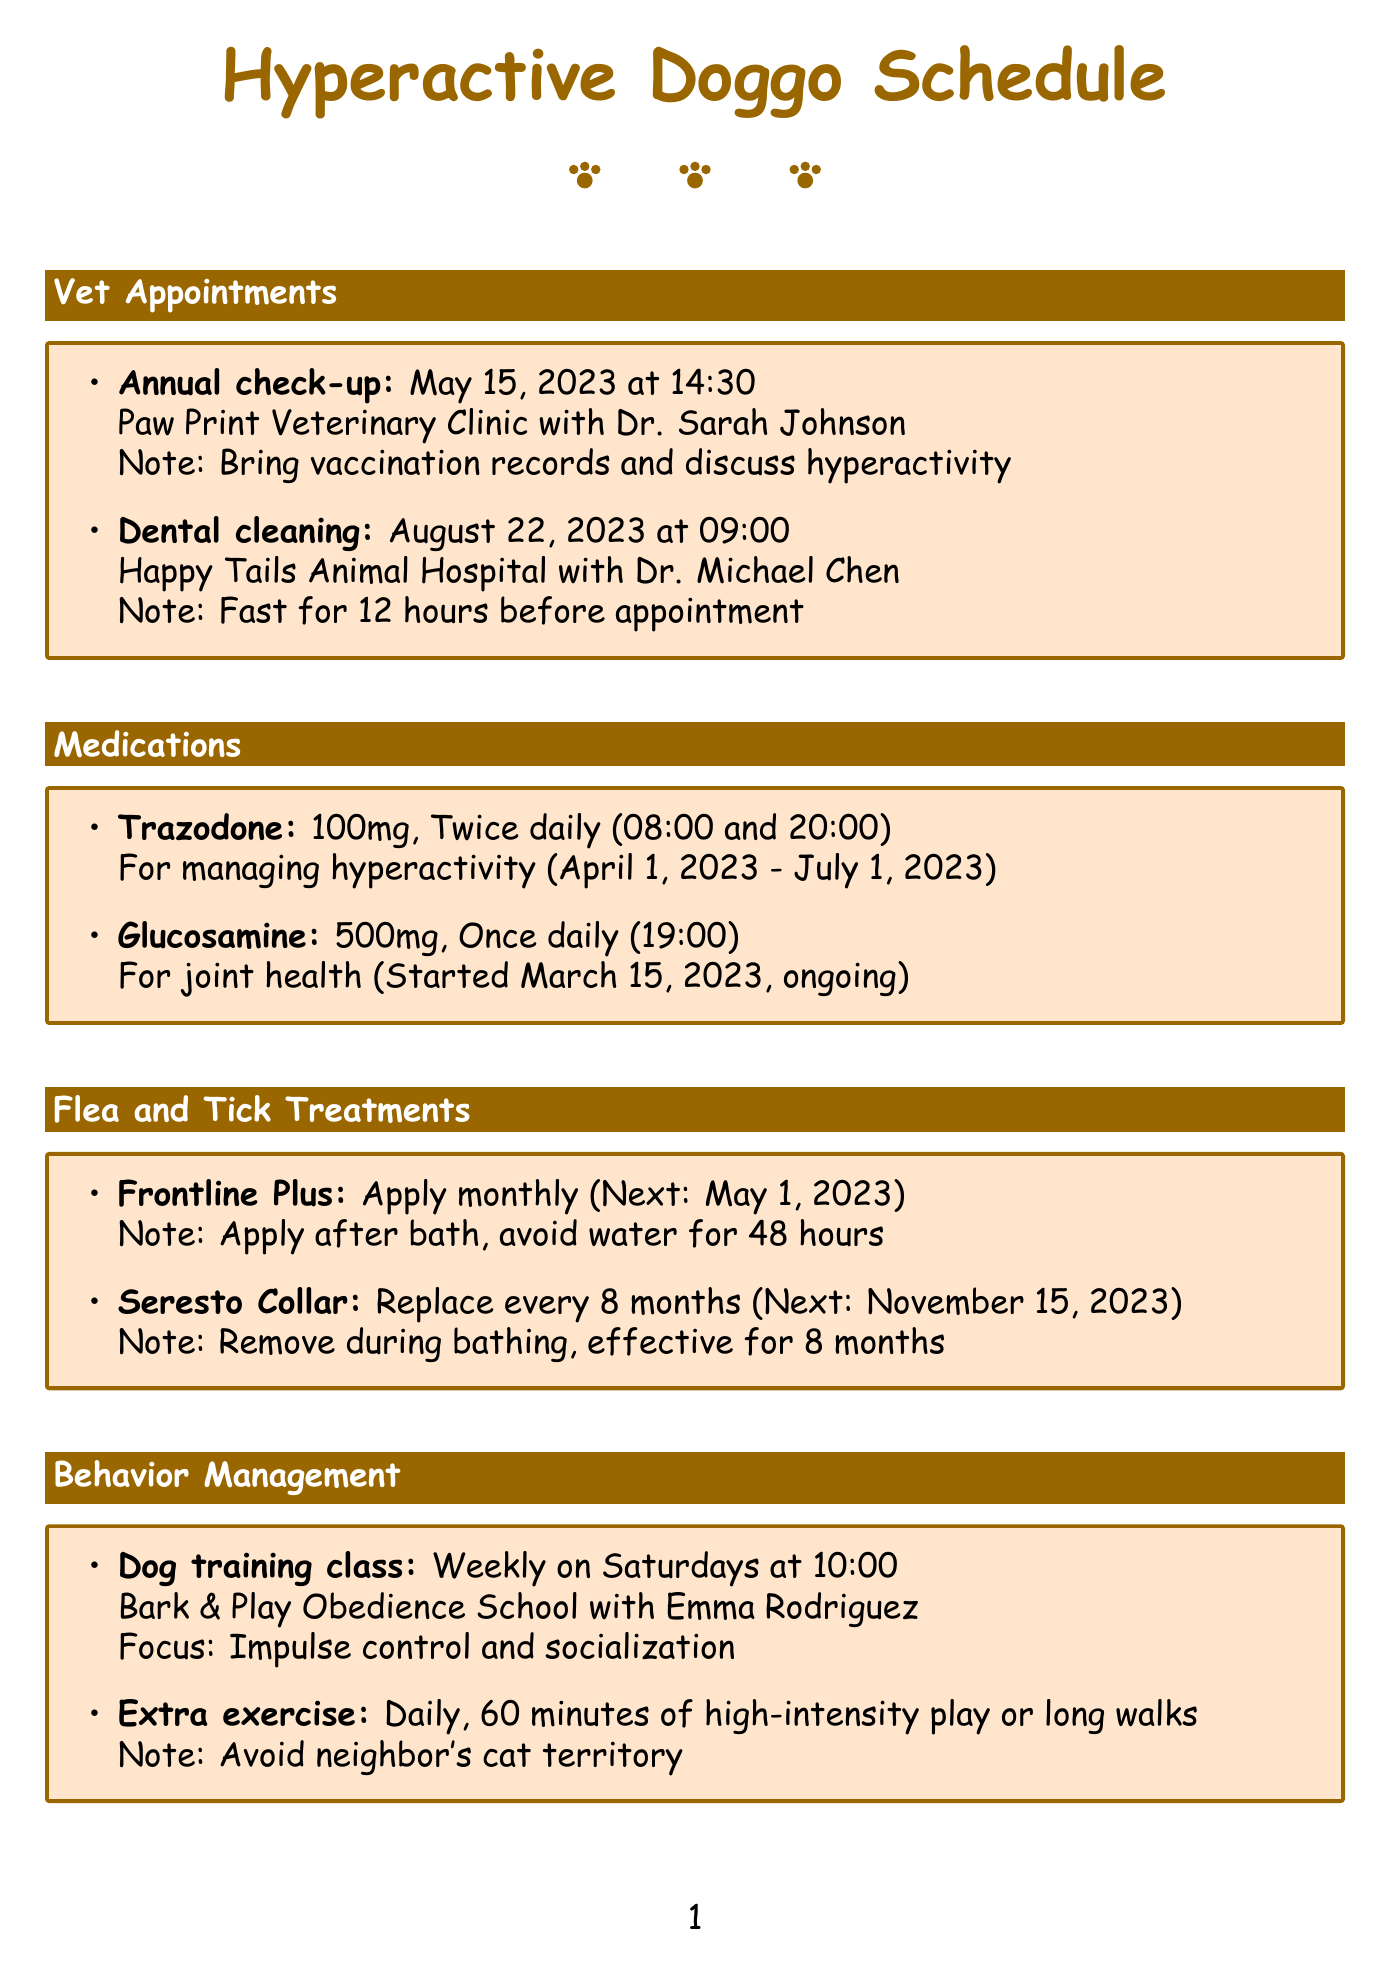what is the date of the annual check-up? The date of the annual check-up can be found in the vet appointments section, which states it is on May 15, 2023.
Answer: May 15, 2023 who is the vet for the dental cleaning? The vet for the dental cleaning is mentioned under the vet appointments section, which names Dr. Michael Chen for that appointment.
Answer: Dr. Michael Chen when is the next application for Frontline Plus? The next application date for Frontline Plus is outlined in the flea and tick treatments section, which indicates it is May 1, 2023.
Answer: May 1, 2023 how often should the Seresto Collar be replaced? The frequency for replacing the Seresto Collar is stated in the flea and tick treatments section as every 8 months.
Answer: Every 8 months what time should Trazodone be given? The medication reminders for Trazodone indicate it should be given at 08:00 and 20:00.
Answer: 08:00 and 20:00 what is the dietary consideration for managing stress? The dietary consideration that helps manage stress is highlighted in the dietary considerations section, which is the Royal Canin Veterinary Diet Calm.
Answer: Royal Canin Veterinary Diet Calm how long is the daily exercise duration for the dog? The behavior management section specifies that the daily exercise duration for the dog is 60 minutes.
Answer: 60 minutes what day of the week is the dog training class held? The dog training class frequency is outlined in the behavior management section, indicating it is held weekly on Saturdays.
Answer: Saturdays 